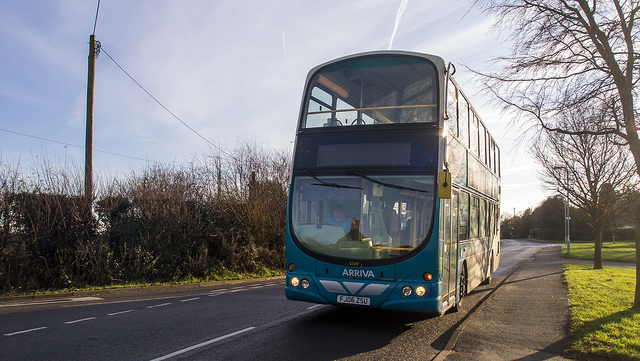<image>Where is the bus going? It is unknown where the bus is going. It could be going forward, south, city, on tour, mall, town, road, or into town. Where is the bus going? I don't know where the bus is going. It can be going forward, south, city, on tour, mall, town or into town. 